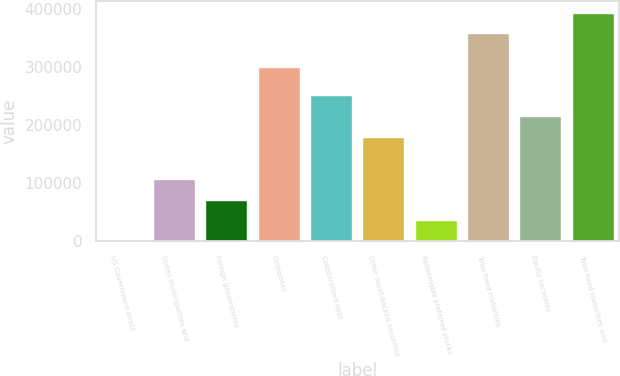Convert chart. <chart><loc_0><loc_0><loc_500><loc_500><bar_chart><fcel>US Government direct<fcel>States municipalities and<fcel>Foreign governments<fcel>Corporates<fcel>Collateralized debt<fcel>Other asset-backed securities<fcel>Redeemable preferred stocks<fcel>Total fixed maturities<fcel>Equity securities<fcel>Total fixed maturities and<nl><fcel>1.28<fcel>107785<fcel>71857.2<fcel>300300<fcel>251497<fcel>179641<fcel>35929.2<fcel>358505<fcel>215569<fcel>394433<nl></chart> 